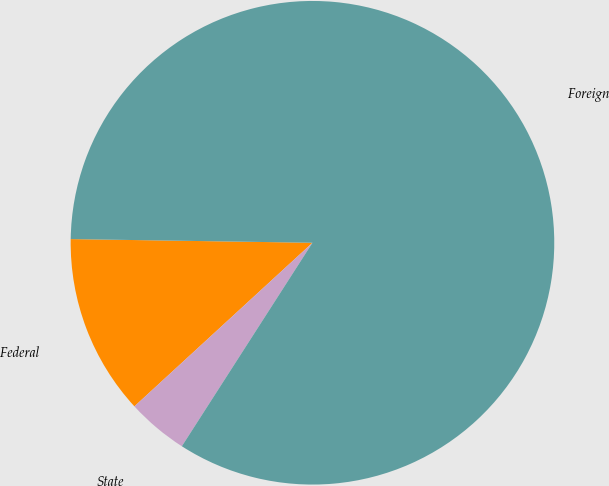Convert chart. <chart><loc_0><loc_0><loc_500><loc_500><pie_chart><fcel>Federal<fcel>State<fcel>Foreign<nl><fcel>12.07%<fcel>4.09%<fcel>83.84%<nl></chart> 